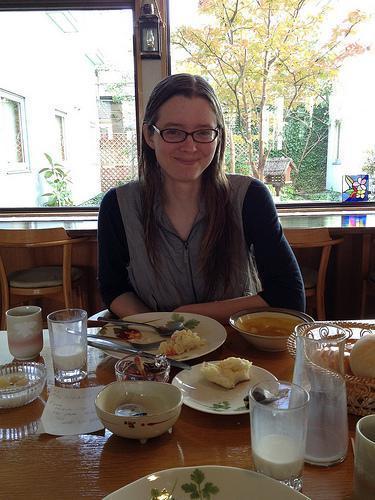How many people?
Give a very brief answer. 1. 